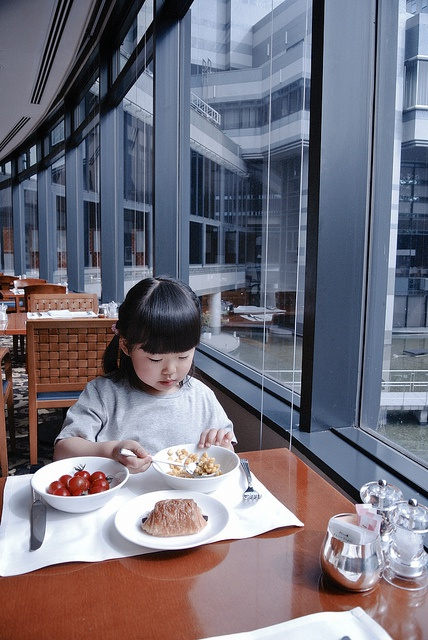Describe the objects in this image and their specific colors. I can see dining table in black, white, darkgray, and brown tones, people in black, lavender, darkgray, and gray tones, chair in black, maroon, and brown tones, bowl in black, lightgray, brown, darkgray, and maroon tones, and bowl in black, white, darkgray, and tan tones in this image. 